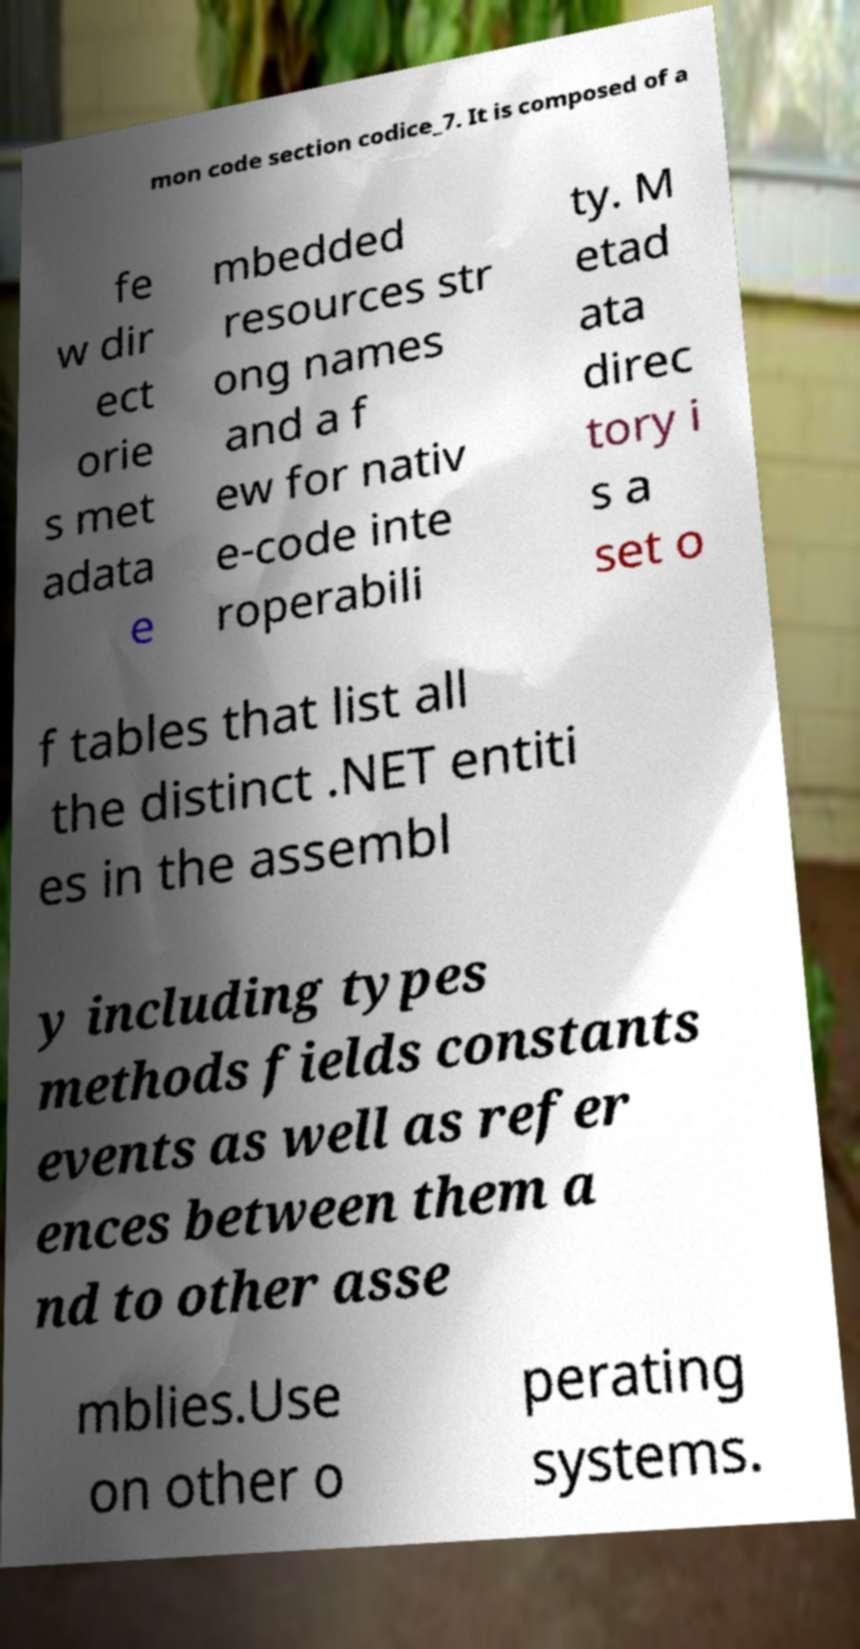There's text embedded in this image that I need extracted. Can you transcribe it verbatim? mon code section codice_7. It is composed of a fe w dir ect orie s met adata e mbedded resources str ong names and a f ew for nativ e-code inte roperabili ty. M etad ata direc tory i s a set o f tables that list all the distinct .NET entiti es in the assembl y including types methods fields constants events as well as refer ences between them a nd to other asse mblies.Use on other o perating systems. 